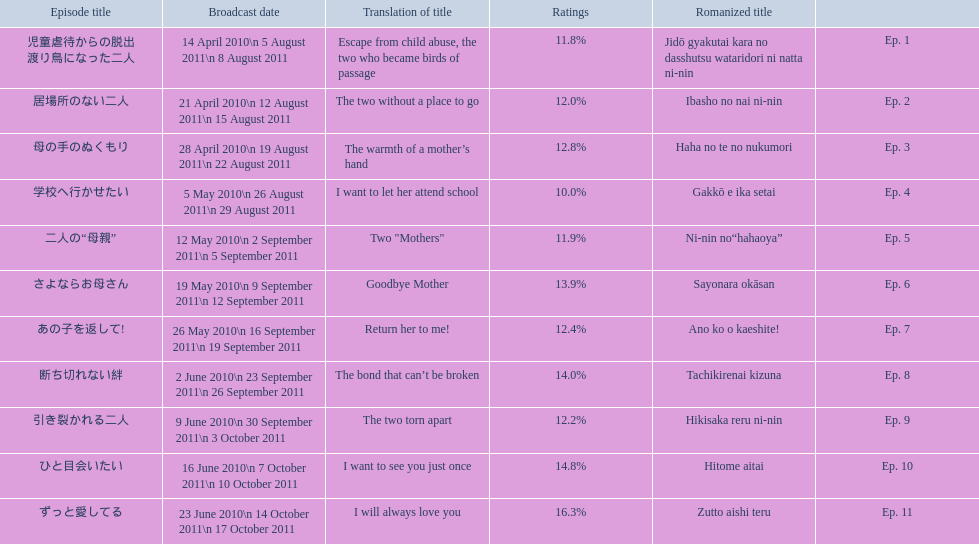What are all the episodes? Ep. 1, Ep. 2, Ep. 3, Ep. 4, Ep. 5, Ep. 6, Ep. 7, Ep. 8, Ep. 9, Ep. 10, Ep. 11. Of these, which ones have a rating of 14%? Ep. 8, Ep. 10. Of these, which one is not ep. 10? Ep. 8. 